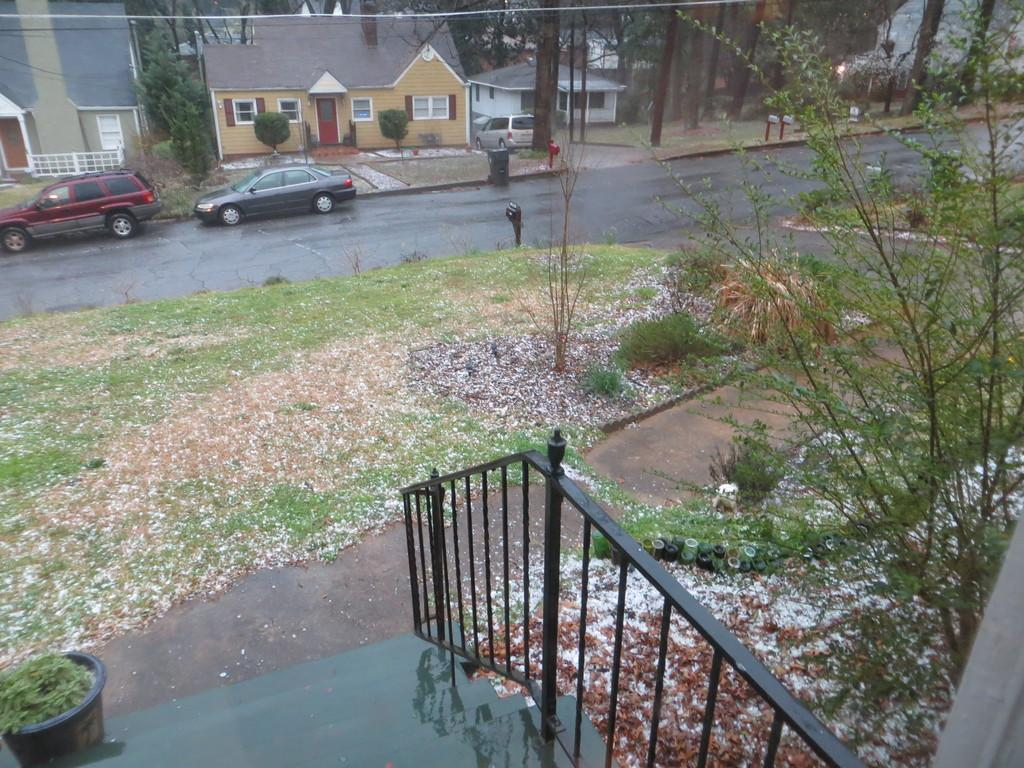What is located at the bottom of the image? There is a staircase and a fence at the bottom of the image. What type of vegetation is present at the bottom of the image? Grass and plants are visible at the bottom of the image. What can be seen in the background of the image? Cars, buildings, trees, and wires are visible in the background of the image. What is the weather like in the image? The image was taken during a rainy day. Can you tell me where the gun is hidden in the image? There is no gun present in the image. What type of jewel is hanging from the trees in the background? There are no jewels present in the image; only trees, buildings, cars, and wires are visible in the background. 